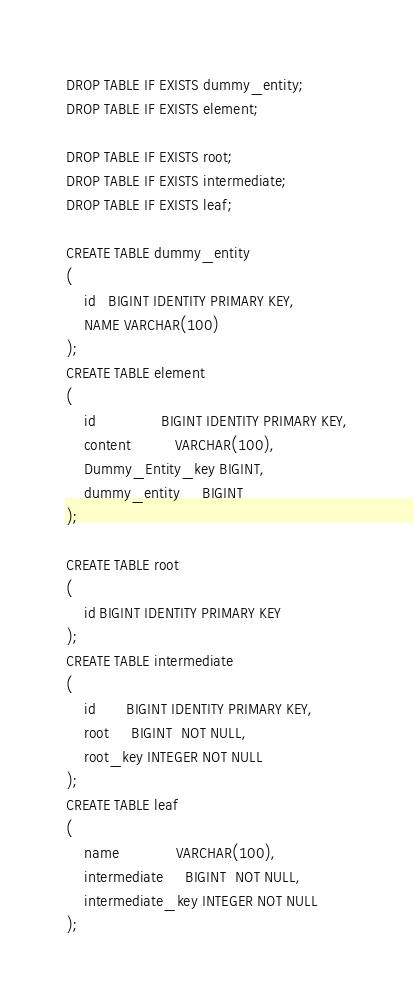Convert code to text. <code><loc_0><loc_0><loc_500><loc_500><_SQL_>DROP TABLE IF EXISTS dummy_entity;
DROP TABLE IF EXISTS element;

DROP TABLE IF EXISTS root;
DROP TABLE IF EXISTS intermediate;
DROP TABLE IF EXISTS leaf;

CREATE TABLE dummy_entity
(
    id   BIGINT IDENTITY PRIMARY KEY,
    NAME VARCHAR(100)
);
CREATE TABLE element
(
    id               BIGINT IDENTITY PRIMARY KEY,
    content          VARCHAR(100),
    Dummy_Entity_key BIGINT,
    dummy_entity     BIGINT
);

CREATE TABLE root
(
    id BIGINT IDENTITY PRIMARY KEY
);
CREATE TABLE intermediate
(
    id       BIGINT IDENTITY PRIMARY KEY,
    root     BIGINT  NOT NULL,
    root_key INTEGER NOT NULL
);
CREATE TABLE leaf
(
    name             VARCHAR(100),
    intermediate     BIGINT  NOT NULL,
    intermediate_key INTEGER NOT NULL
);
</code> 